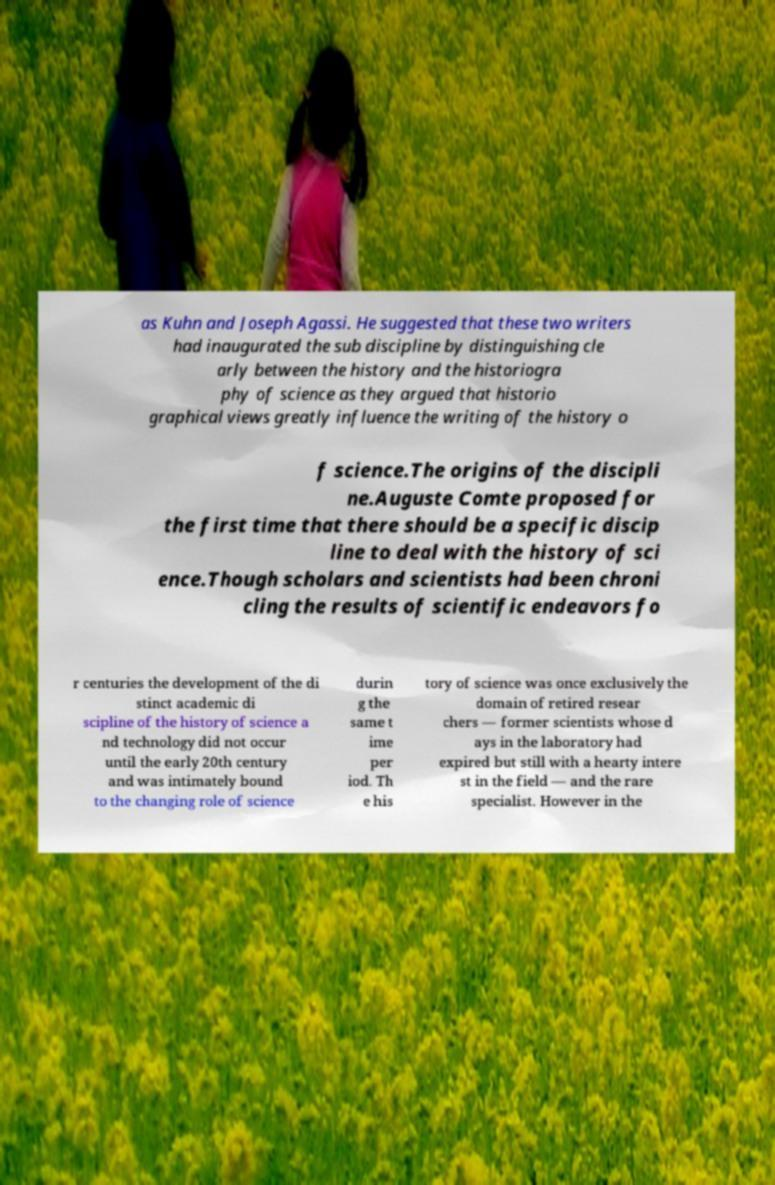There's text embedded in this image that I need extracted. Can you transcribe it verbatim? as Kuhn and Joseph Agassi. He suggested that these two writers had inaugurated the sub discipline by distinguishing cle arly between the history and the historiogra phy of science as they argued that historio graphical views greatly influence the writing of the history o f science.The origins of the discipli ne.Auguste Comte proposed for the first time that there should be a specific discip line to deal with the history of sci ence.Though scholars and scientists had been chroni cling the results of scientific endeavors fo r centuries the development of the di stinct academic di scipline of the history of science a nd technology did not occur until the early 20th century and was intimately bound to the changing role of science durin g the same t ime per iod. Th e his tory of science was once exclusively the domain of retired resear chers — former scientists whose d ays in the laboratory had expired but still with a hearty intere st in the field — and the rare specialist. However in the 